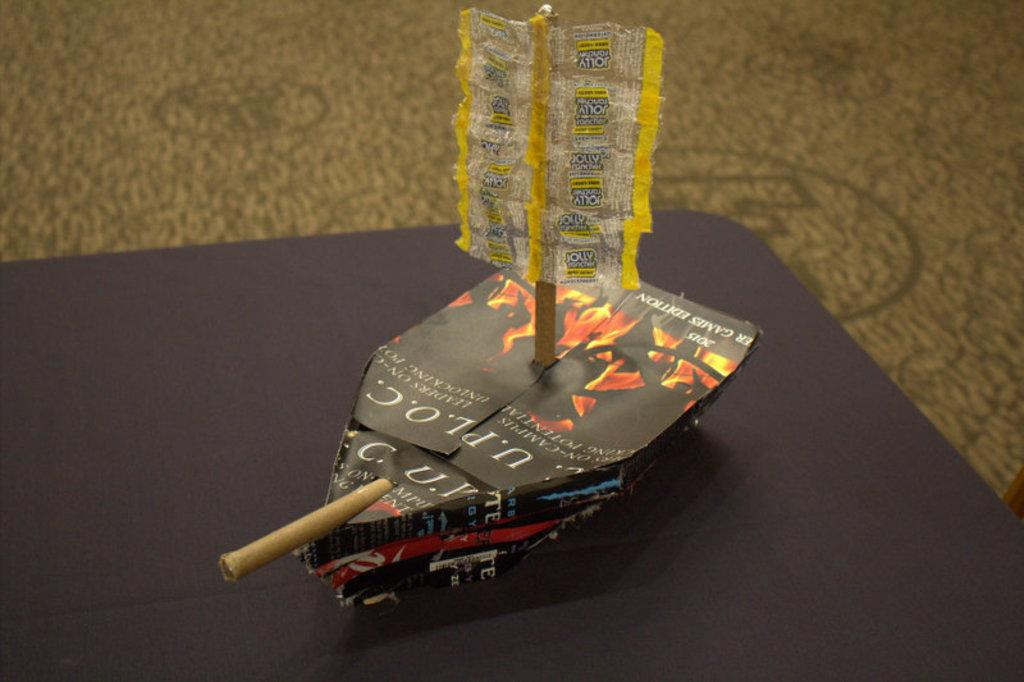What is the main object in the image? There is a paper boat in the image. Where is the paper boat located? The paper boat is on a table. What type of tent is set up next to the paper boat on the table? There is no tent present in the image; it only features a paper boat on a table. 